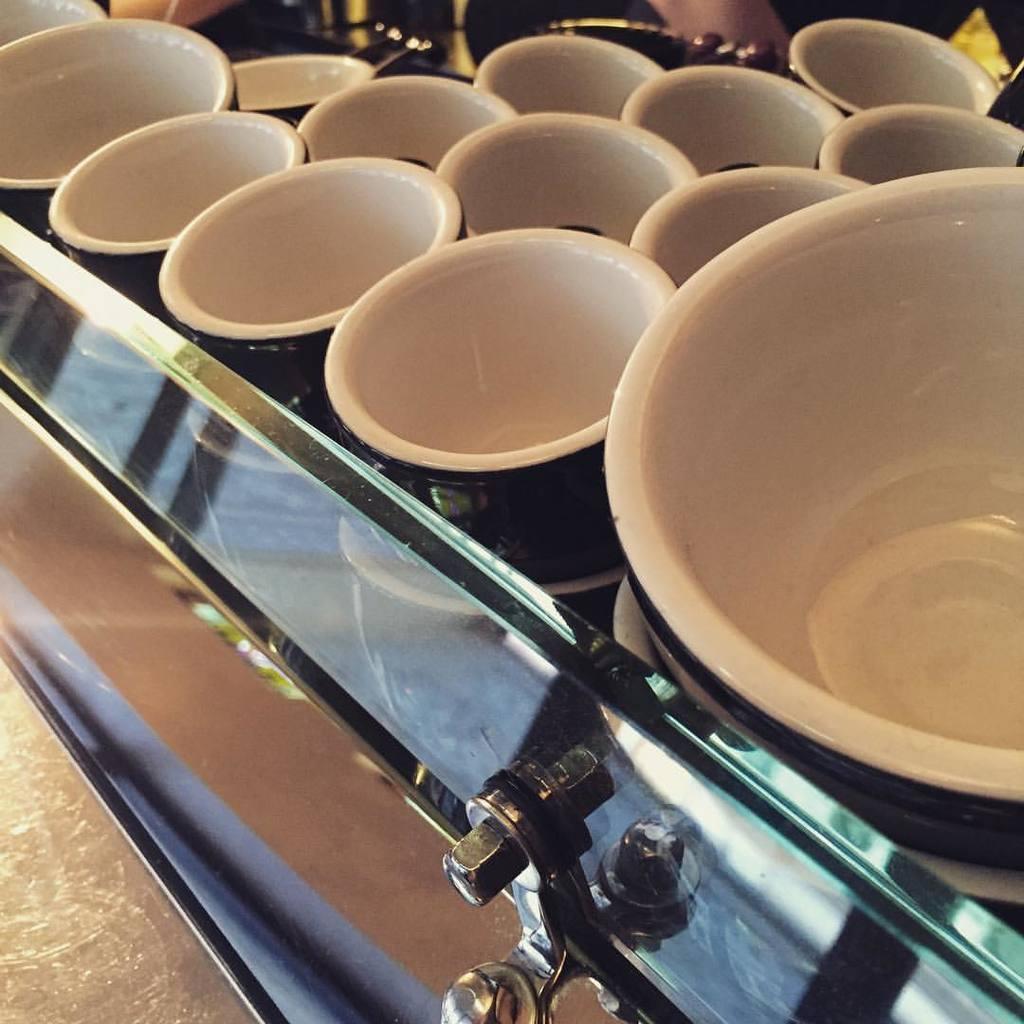Can you describe this image briefly? In this image in the center there are some bowls, and at the bottom there is a bolt and some objects. 